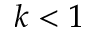<formula> <loc_0><loc_0><loc_500><loc_500>k < 1</formula> 